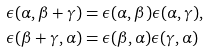Convert formula to latex. <formula><loc_0><loc_0><loc_500><loc_500>\epsilon ( \alpha , \beta + \gamma ) & = \epsilon ( \alpha , \beta ) \epsilon ( \alpha , \gamma ) , \\ \epsilon ( \beta + \gamma , \alpha ) & = \epsilon ( \beta , \alpha ) \epsilon ( \gamma , \alpha )</formula> 